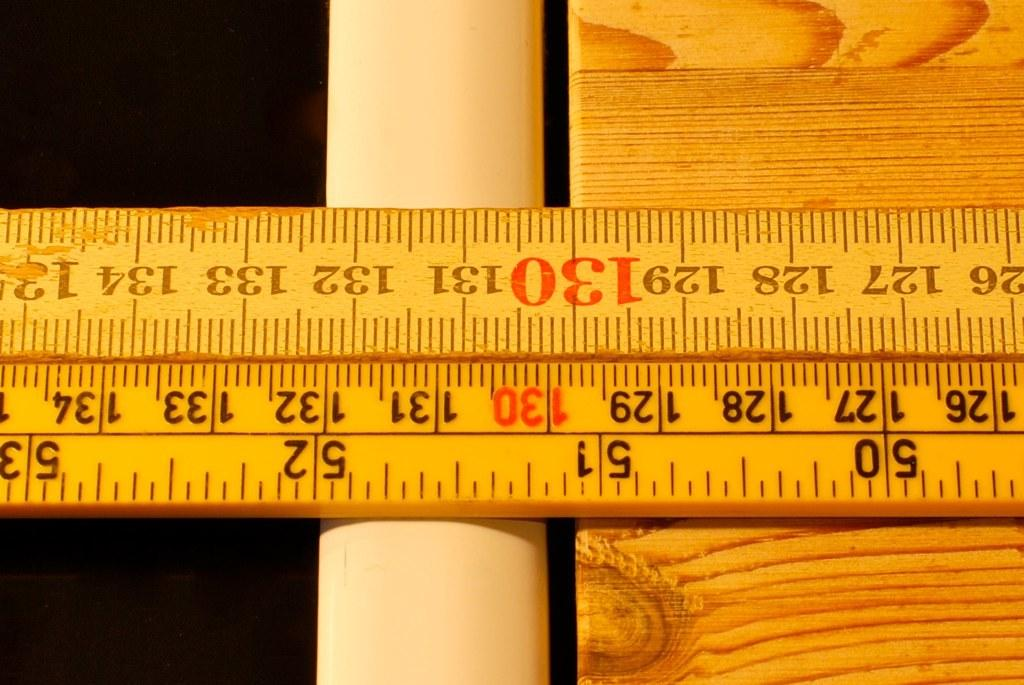<image>
Relay a brief, clear account of the picture shown. a ruler that has the number 130 in bold red 